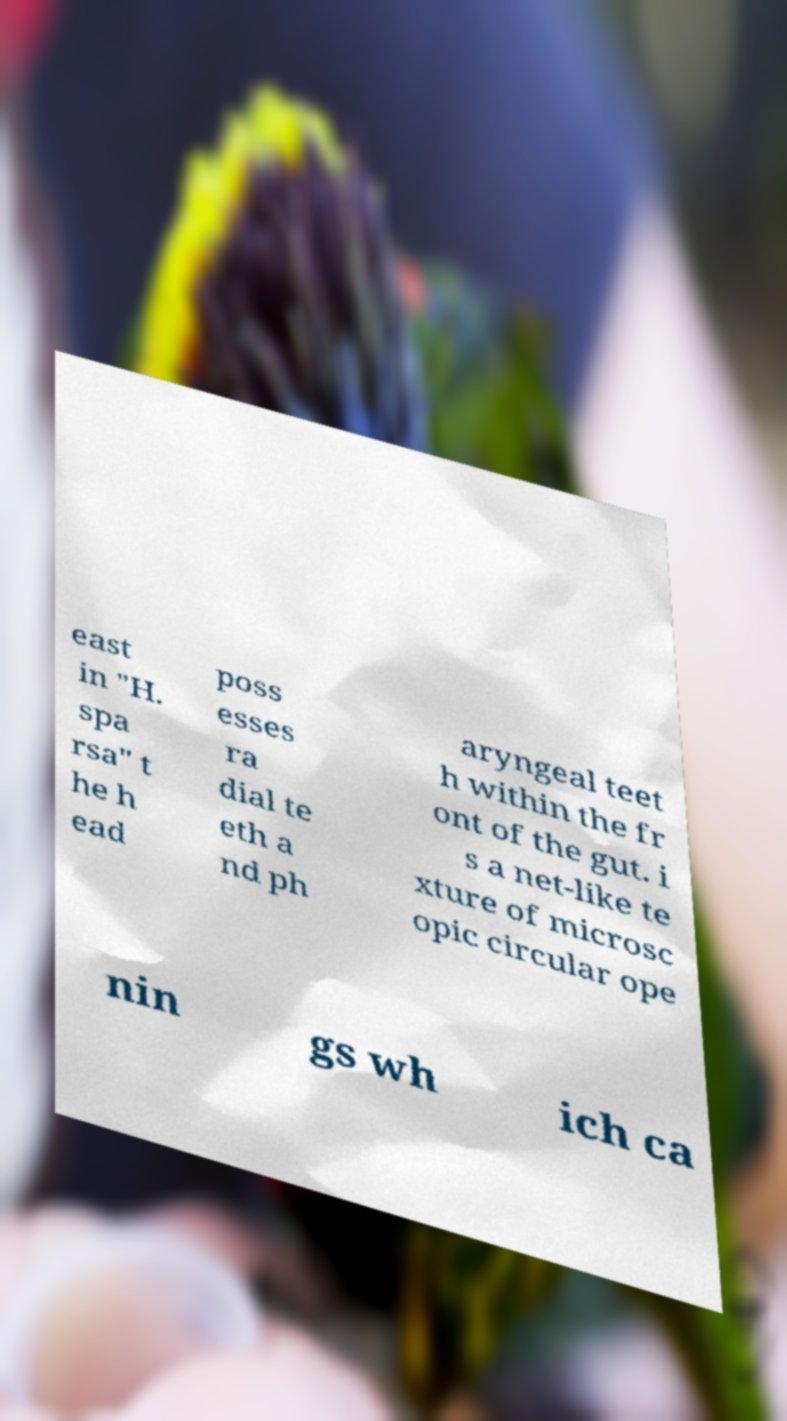For documentation purposes, I need the text within this image transcribed. Could you provide that? east in "H. spa rsa" t he h ead poss esses ra dial te eth a nd ph aryngeal teet h within the fr ont of the gut. i s a net-like te xture of microsc opic circular ope nin gs wh ich ca 